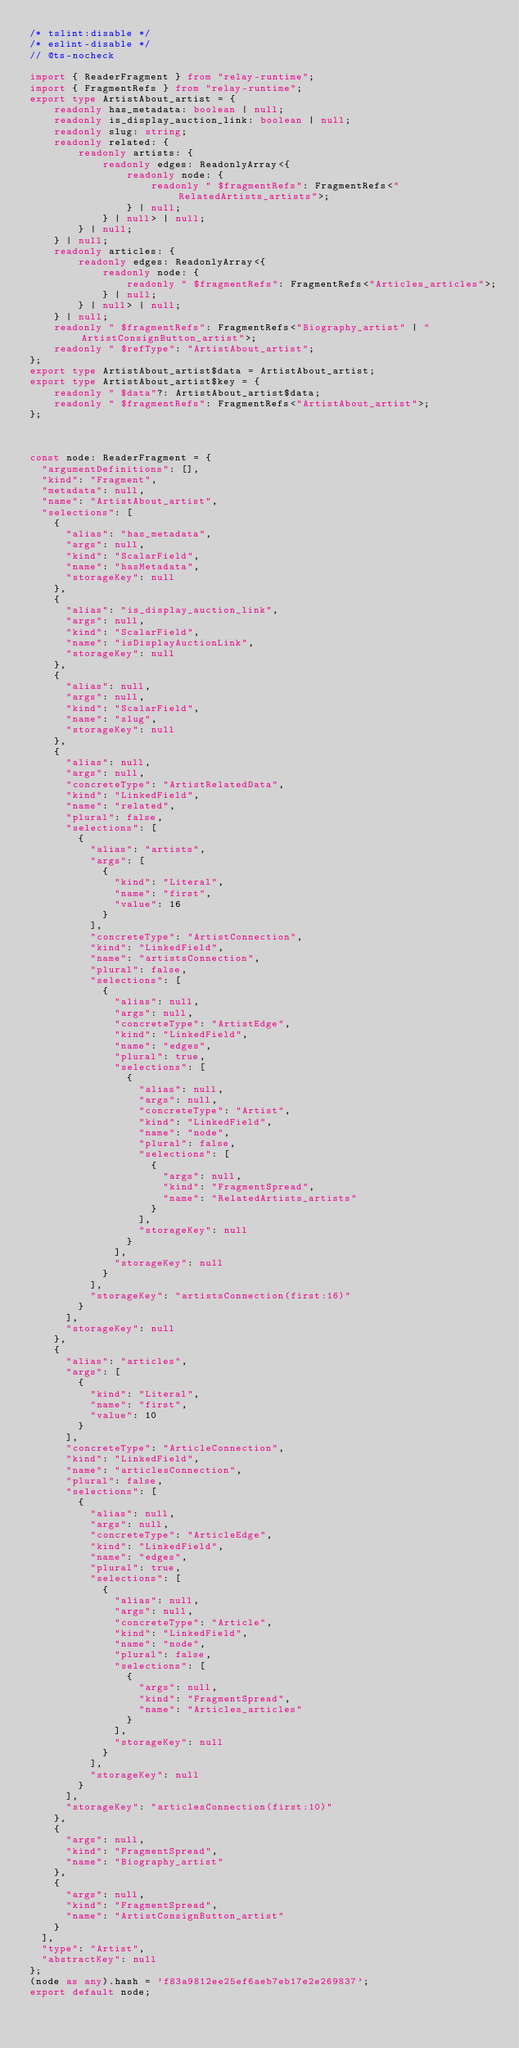Convert code to text. <code><loc_0><loc_0><loc_500><loc_500><_TypeScript_>/* tslint:disable */
/* eslint-disable */
// @ts-nocheck

import { ReaderFragment } from "relay-runtime";
import { FragmentRefs } from "relay-runtime";
export type ArtistAbout_artist = {
    readonly has_metadata: boolean | null;
    readonly is_display_auction_link: boolean | null;
    readonly slug: string;
    readonly related: {
        readonly artists: {
            readonly edges: ReadonlyArray<{
                readonly node: {
                    readonly " $fragmentRefs": FragmentRefs<"RelatedArtists_artists">;
                } | null;
            } | null> | null;
        } | null;
    } | null;
    readonly articles: {
        readonly edges: ReadonlyArray<{
            readonly node: {
                readonly " $fragmentRefs": FragmentRefs<"Articles_articles">;
            } | null;
        } | null> | null;
    } | null;
    readonly " $fragmentRefs": FragmentRefs<"Biography_artist" | "ArtistConsignButton_artist">;
    readonly " $refType": "ArtistAbout_artist";
};
export type ArtistAbout_artist$data = ArtistAbout_artist;
export type ArtistAbout_artist$key = {
    readonly " $data"?: ArtistAbout_artist$data;
    readonly " $fragmentRefs": FragmentRefs<"ArtistAbout_artist">;
};



const node: ReaderFragment = {
  "argumentDefinitions": [],
  "kind": "Fragment",
  "metadata": null,
  "name": "ArtistAbout_artist",
  "selections": [
    {
      "alias": "has_metadata",
      "args": null,
      "kind": "ScalarField",
      "name": "hasMetadata",
      "storageKey": null
    },
    {
      "alias": "is_display_auction_link",
      "args": null,
      "kind": "ScalarField",
      "name": "isDisplayAuctionLink",
      "storageKey": null
    },
    {
      "alias": null,
      "args": null,
      "kind": "ScalarField",
      "name": "slug",
      "storageKey": null
    },
    {
      "alias": null,
      "args": null,
      "concreteType": "ArtistRelatedData",
      "kind": "LinkedField",
      "name": "related",
      "plural": false,
      "selections": [
        {
          "alias": "artists",
          "args": [
            {
              "kind": "Literal",
              "name": "first",
              "value": 16
            }
          ],
          "concreteType": "ArtistConnection",
          "kind": "LinkedField",
          "name": "artistsConnection",
          "plural": false,
          "selections": [
            {
              "alias": null,
              "args": null,
              "concreteType": "ArtistEdge",
              "kind": "LinkedField",
              "name": "edges",
              "plural": true,
              "selections": [
                {
                  "alias": null,
                  "args": null,
                  "concreteType": "Artist",
                  "kind": "LinkedField",
                  "name": "node",
                  "plural": false,
                  "selections": [
                    {
                      "args": null,
                      "kind": "FragmentSpread",
                      "name": "RelatedArtists_artists"
                    }
                  ],
                  "storageKey": null
                }
              ],
              "storageKey": null
            }
          ],
          "storageKey": "artistsConnection(first:16)"
        }
      ],
      "storageKey": null
    },
    {
      "alias": "articles",
      "args": [
        {
          "kind": "Literal",
          "name": "first",
          "value": 10
        }
      ],
      "concreteType": "ArticleConnection",
      "kind": "LinkedField",
      "name": "articlesConnection",
      "plural": false,
      "selections": [
        {
          "alias": null,
          "args": null,
          "concreteType": "ArticleEdge",
          "kind": "LinkedField",
          "name": "edges",
          "plural": true,
          "selections": [
            {
              "alias": null,
              "args": null,
              "concreteType": "Article",
              "kind": "LinkedField",
              "name": "node",
              "plural": false,
              "selections": [
                {
                  "args": null,
                  "kind": "FragmentSpread",
                  "name": "Articles_articles"
                }
              ],
              "storageKey": null
            }
          ],
          "storageKey": null
        }
      ],
      "storageKey": "articlesConnection(first:10)"
    },
    {
      "args": null,
      "kind": "FragmentSpread",
      "name": "Biography_artist"
    },
    {
      "args": null,
      "kind": "FragmentSpread",
      "name": "ArtistConsignButton_artist"
    }
  ],
  "type": "Artist",
  "abstractKey": null
};
(node as any).hash = 'f83a9812ee25ef6aeb7eb17e2e269837';
export default node;
</code> 